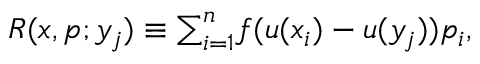<formula> <loc_0><loc_0><loc_500><loc_500>\begin{array} { r } { R ( x , p ; y _ { j } ) \equiv \sum _ { i = 1 } ^ { n } f ( u ( x _ { i } ) - u ( y _ { j } ) ) p _ { i } , } \end{array}</formula> 